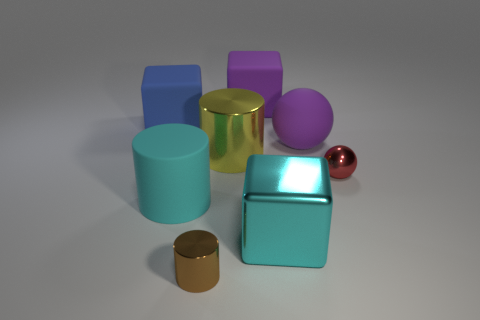Add 1 brown metal things. How many objects exist? 9 Subtract all cylinders. How many objects are left? 5 Subtract all large purple rubber cylinders. Subtract all purple cubes. How many objects are left? 7 Add 1 cyan shiny objects. How many cyan shiny objects are left? 2 Add 1 tiny brown shiny cylinders. How many tiny brown shiny cylinders exist? 2 Subtract 1 purple blocks. How many objects are left? 7 